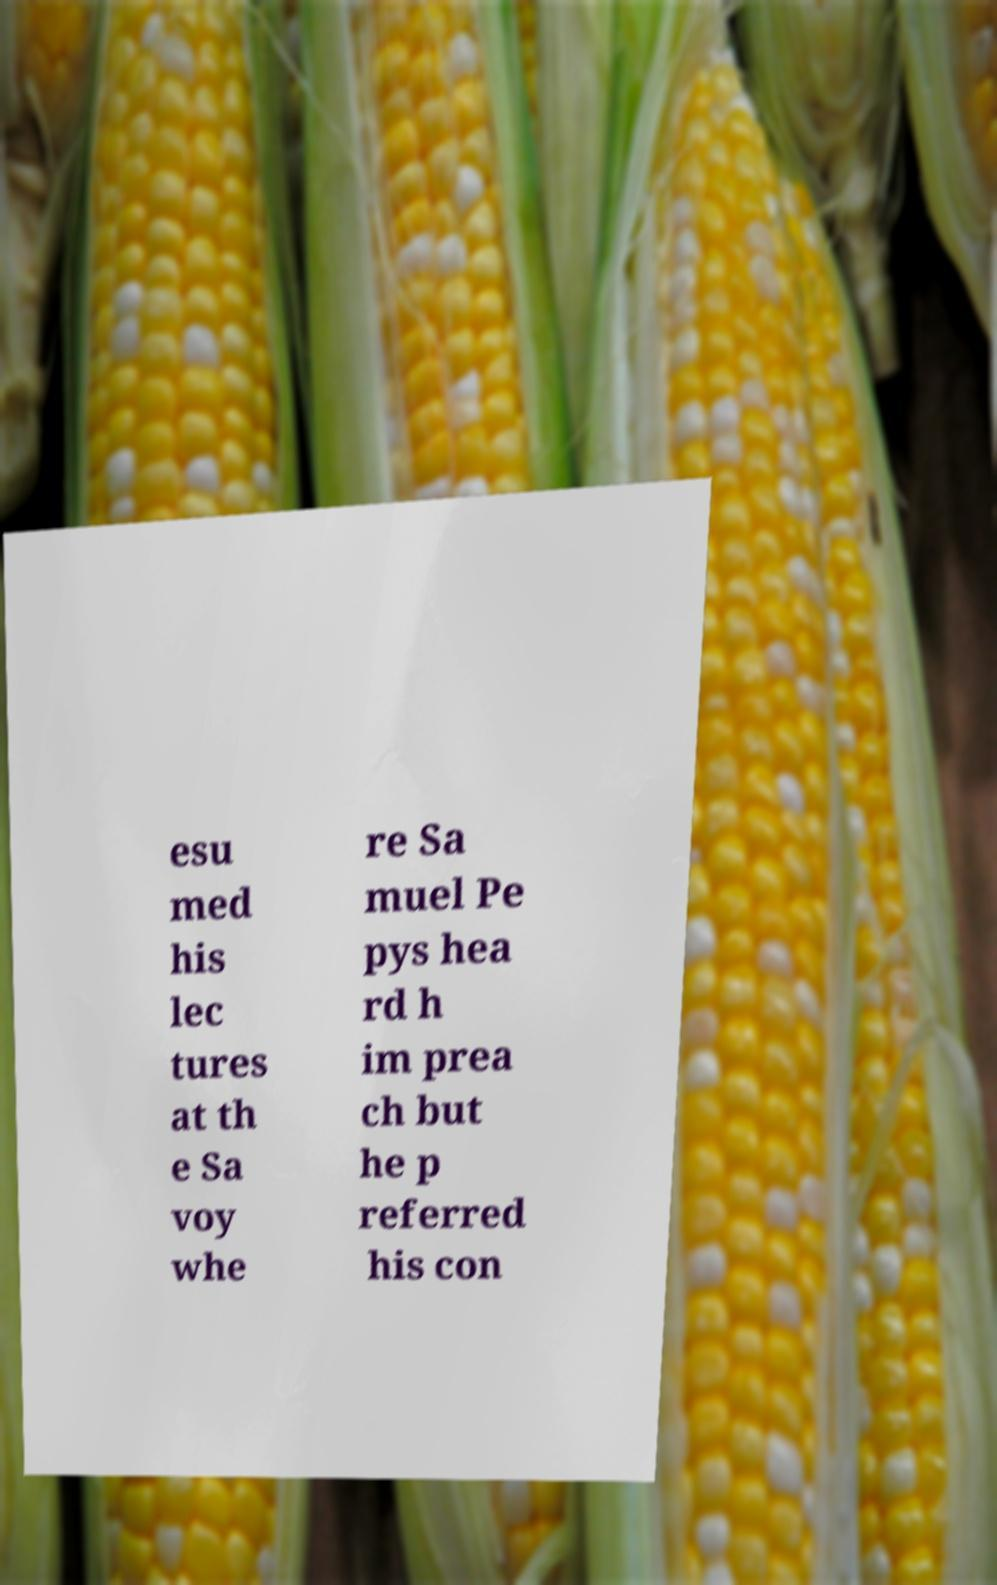Please identify and transcribe the text found in this image. esu med his lec tures at th e Sa voy whe re Sa muel Pe pys hea rd h im prea ch but he p referred his con 